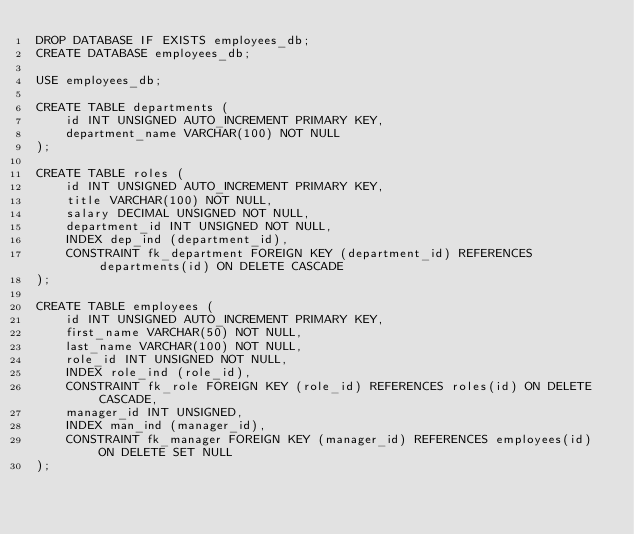<code> <loc_0><loc_0><loc_500><loc_500><_SQL_>DROP DATABASE IF EXISTS employees_db;
CREATE DATABASE employees_db;

USE employees_db;

CREATE TABLE departments (
    id INT UNSIGNED AUTO_INCREMENT PRIMARY KEY,
    department_name VARCHAR(100) NOT NULL
);

CREATE TABLE roles (
    id INT UNSIGNED AUTO_INCREMENT PRIMARY KEY,
    title VARCHAR(100) NOT NULL,
    salary DECIMAL UNSIGNED NOT NULL,
    department_id INT UNSIGNED NOT NULL,
    INDEX dep_ind (department_id),
    CONSTRAINT fk_department FOREIGN KEY (department_id) REFERENCES departments(id) ON DELETE CASCADE
);

CREATE TABLE employees (
    id INT UNSIGNED AUTO_INCREMENT PRIMARY KEY,
    first_name VARCHAR(50) NOT NULL,
    last_name VARCHAR(100) NOT NULL,
    role_id INT UNSIGNED NOT NULL,
    INDEX role_ind (role_id),
    CONSTRAINT fk_role FOREIGN KEY (role_id) REFERENCES roles(id) ON DELETE CASCADE,
    manager_id INT UNSIGNED,
    INDEX man_ind (manager_id),
    CONSTRAINT fk_manager FOREIGN KEY (manager_id) REFERENCES employees(id) ON DELETE SET NULL
);</code> 